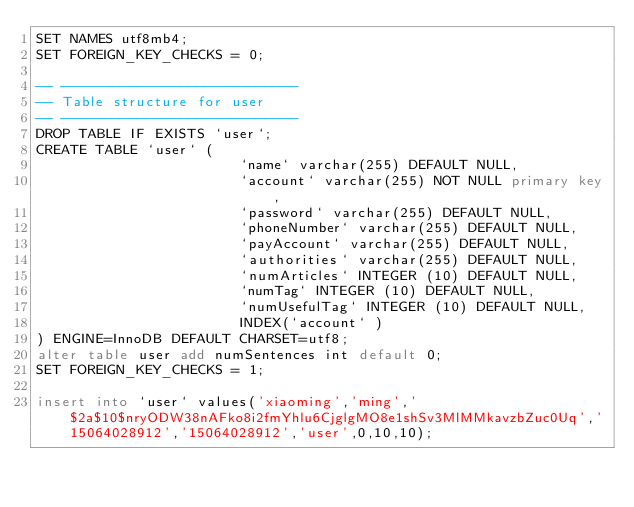Convert code to text. <code><loc_0><loc_0><loc_500><loc_500><_SQL_>SET NAMES utf8mb4;
SET FOREIGN_KEY_CHECKS = 0;

-- ----------------------------
-- Table structure for user
-- ----------------------------
DROP TABLE IF EXISTS `user`;
CREATE TABLE `user` (
                        `name` varchar(255) DEFAULT NULL,
                        `account` varchar(255) NOT NULL primary key,
                        `password` varchar(255) DEFAULT NULL,
                        `phoneNumber` varchar(255) DEFAULT NULL,
                        `payAccount` varchar(255) DEFAULT NULL,
                        `authorities` varchar(255) DEFAULT NULL,
                        `numArticles` INTEGER (10) DEFAULT NULL,
                        `numTag` INTEGER (10) DEFAULT NULL,
                        `numUsefulTag` INTEGER (10) DEFAULT NULL,
                        INDEX(`account` )
) ENGINE=InnoDB DEFAULT CHARSET=utf8;
alter table user add numSentences int default 0;
SET FOREIGN_KEY_CHECKS = 1;

insert into `user` values('xiaoming','ming','$2a$10$nryODW38nAFko8i2fmYhlu6CjglgMO8e1shSv3MlMMkavzbZuc0Uq','15064028912','15064028912','user',0,10,10);</code> 